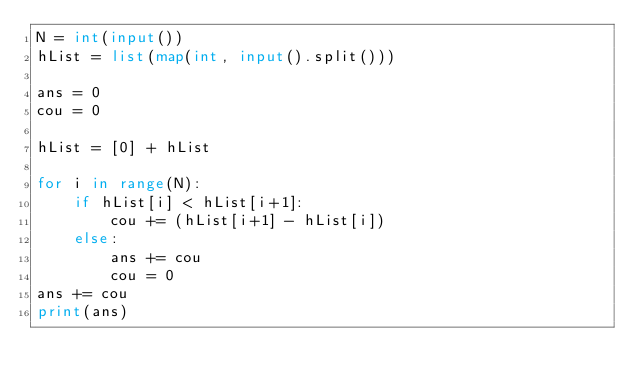<code> <loc_0><loc_0><loc_500><loc_500><_Python_>N = int(input())
hList = list(map(int, input().split()))

ans = 0
cou = 0

hList = [0] + hList

for i in range(N):
    if hList[i] < hList[i+1]:
        cou += (hList[i+1] - hList[i])
    else:
        ans += cou
        cou = 0
ans += cou
print(ans)</code> 